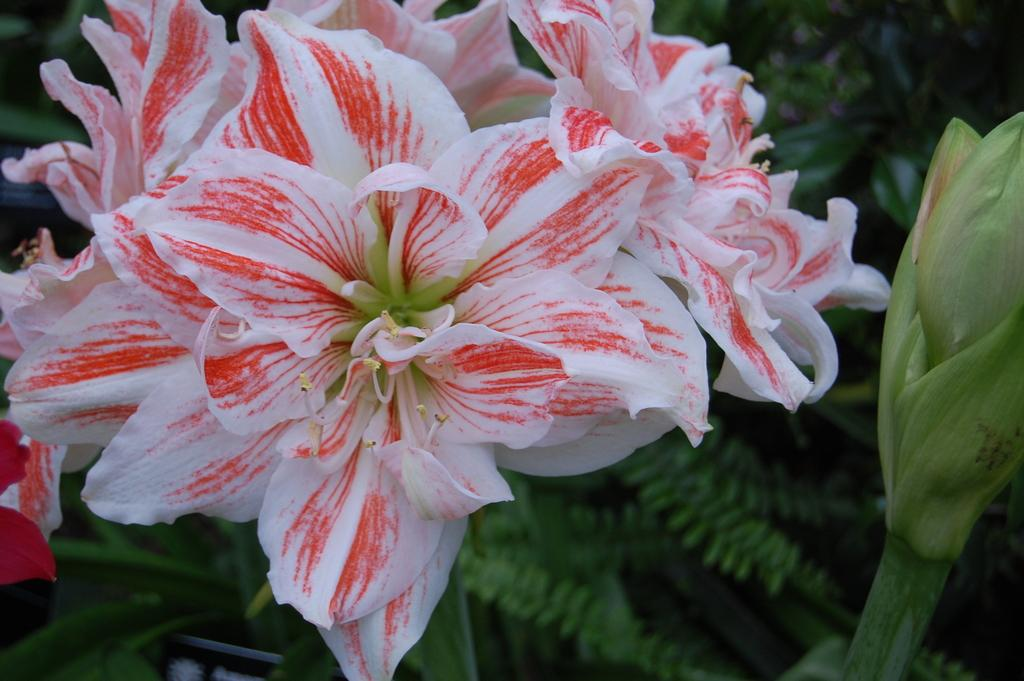What type of flower is featured in the image? There is a white flower with a red shade in the image. What can be seen in the background of the image? There are leaves in the background of the image. Where is the bud located in the image? The bud is on the right side of the image. What part of the flower is visible in the image? The flower has a stigma. What type of apparel is the flower wearing in the image? Flowers do not wear apparel, so this question cannot be answered. 